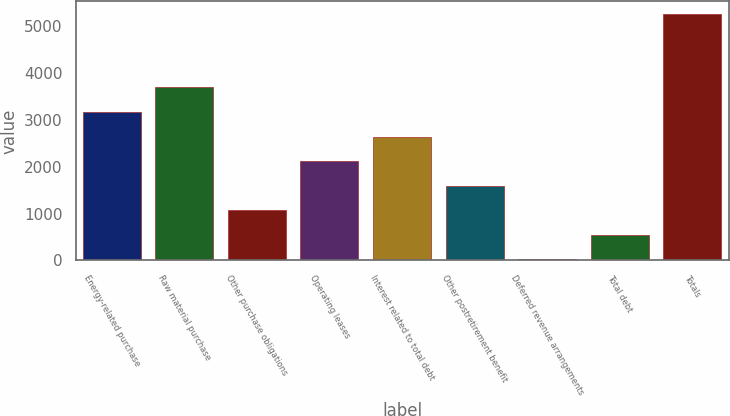Convert chart. <chart><loc_0><loc_0><loc_500><loc_500><bar_chart><fcel>Energy-related purchase<fcel>Raw material purchase<fcel>Other purchase obligations<fcel>Operating leases<fcel>Interest related to total debt<fcel>Other postretirement benefit<fcel>Deferred revenue arrangements<fcel>Total debt<fcel>Totals<nl><fcel>3171.2<fcel>3696.4<fcel>1070.4<fcel>2120.8<fcel>2646<fcel>1595.6<fcel>20<fcel>545.2<fcel>5272<nl></chart> 